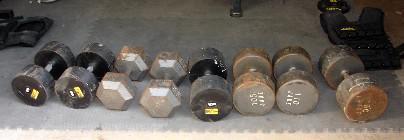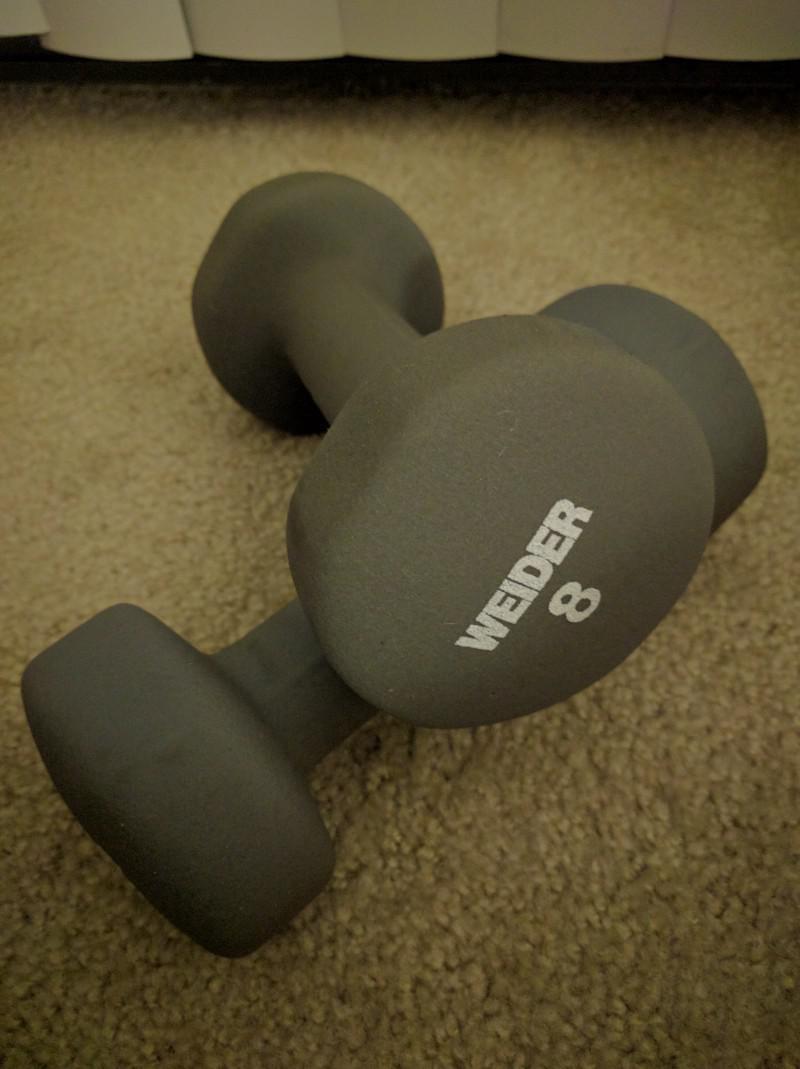The first image is the image on the left, the second image is the image on the right. For the images displayed, is the sentence "All of the weights are round." factually correct? Answer yes or no. No. 